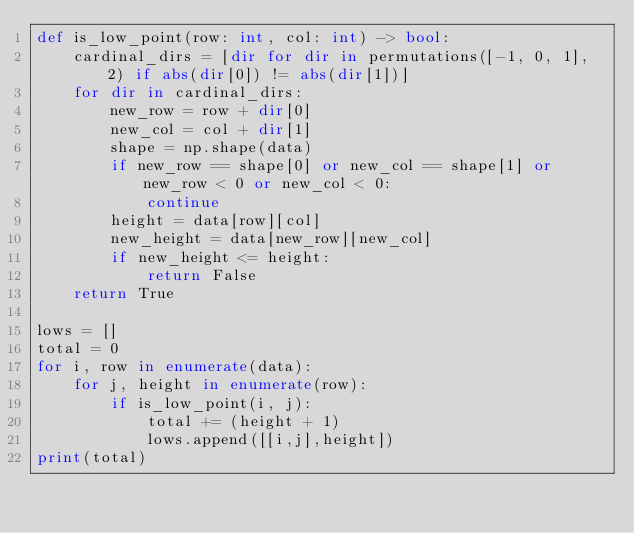Convert code to text. <code><loc_0><loc_0><loc_500><loc_500><_Python_>def is_low_point(row: int, col: int) -> bool:
    cardinal_dirs = [dir for dir in permutations([-1, 0, 1], 2) if abs(dir[0]) != abs(dir[1])]
    for dir in cardinal_dirs:
        new_row = row + dir[0]
        new_col = col + dir[1]
        shape = np.shape(data)
        if new_row == shape[0] or new_col == shape[1] or new_row < 0 or new_col < 0:
            continue
        height = data[row][col]
        new_height = data[new_row][new_col]
        if new_height <= height:
            return False
    return True

lows = []
total = 0
for i, row in enumerate(data):
    for j, height in enumerate(row):
        if is_low_point(i, j):
            total += (height + 1)
            lows.append([[i,j],height])
print(total)

</code> 